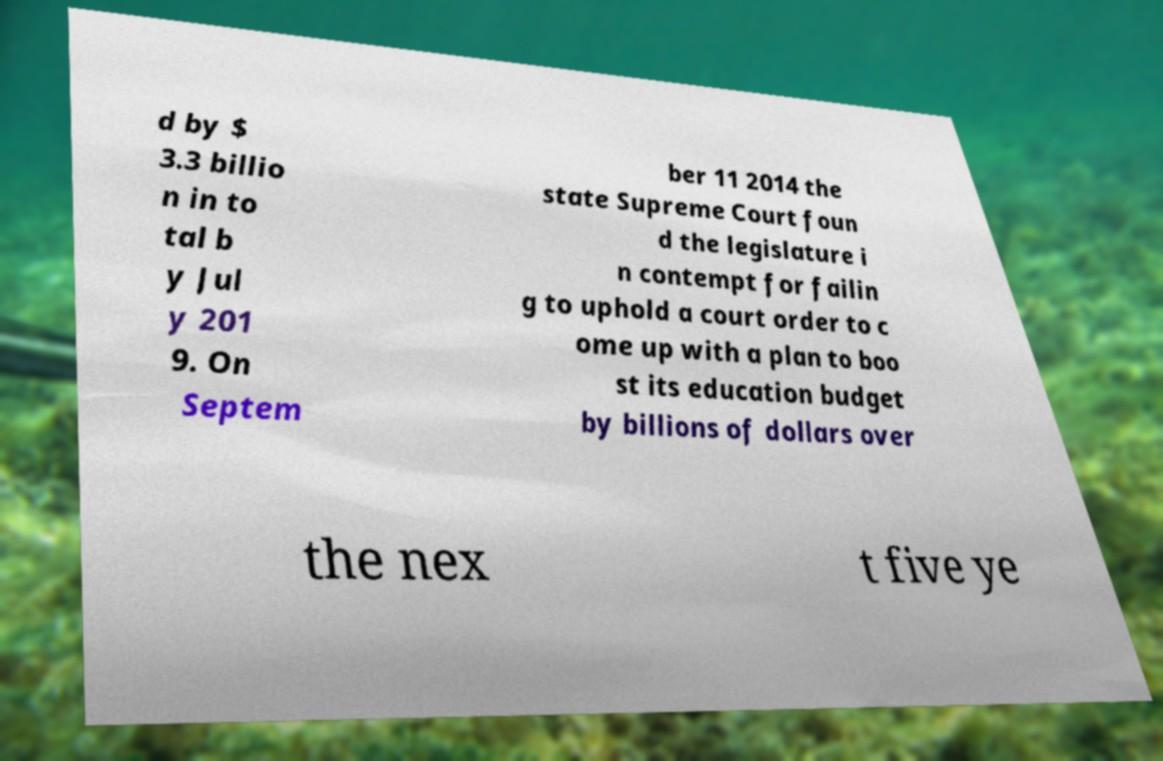For documentation purposes, I need the text within this image transcribed. Could you provide that? d by $ 3.3 billio n in to tal b y Jul y 201 9. On Septem ber 11 2014 the state Supreme Court foun d the legislature i n contempt for failin g to uphold a court order to c ome up with a plan to boo st its education budget by billions of dollars over the nex t five ye 